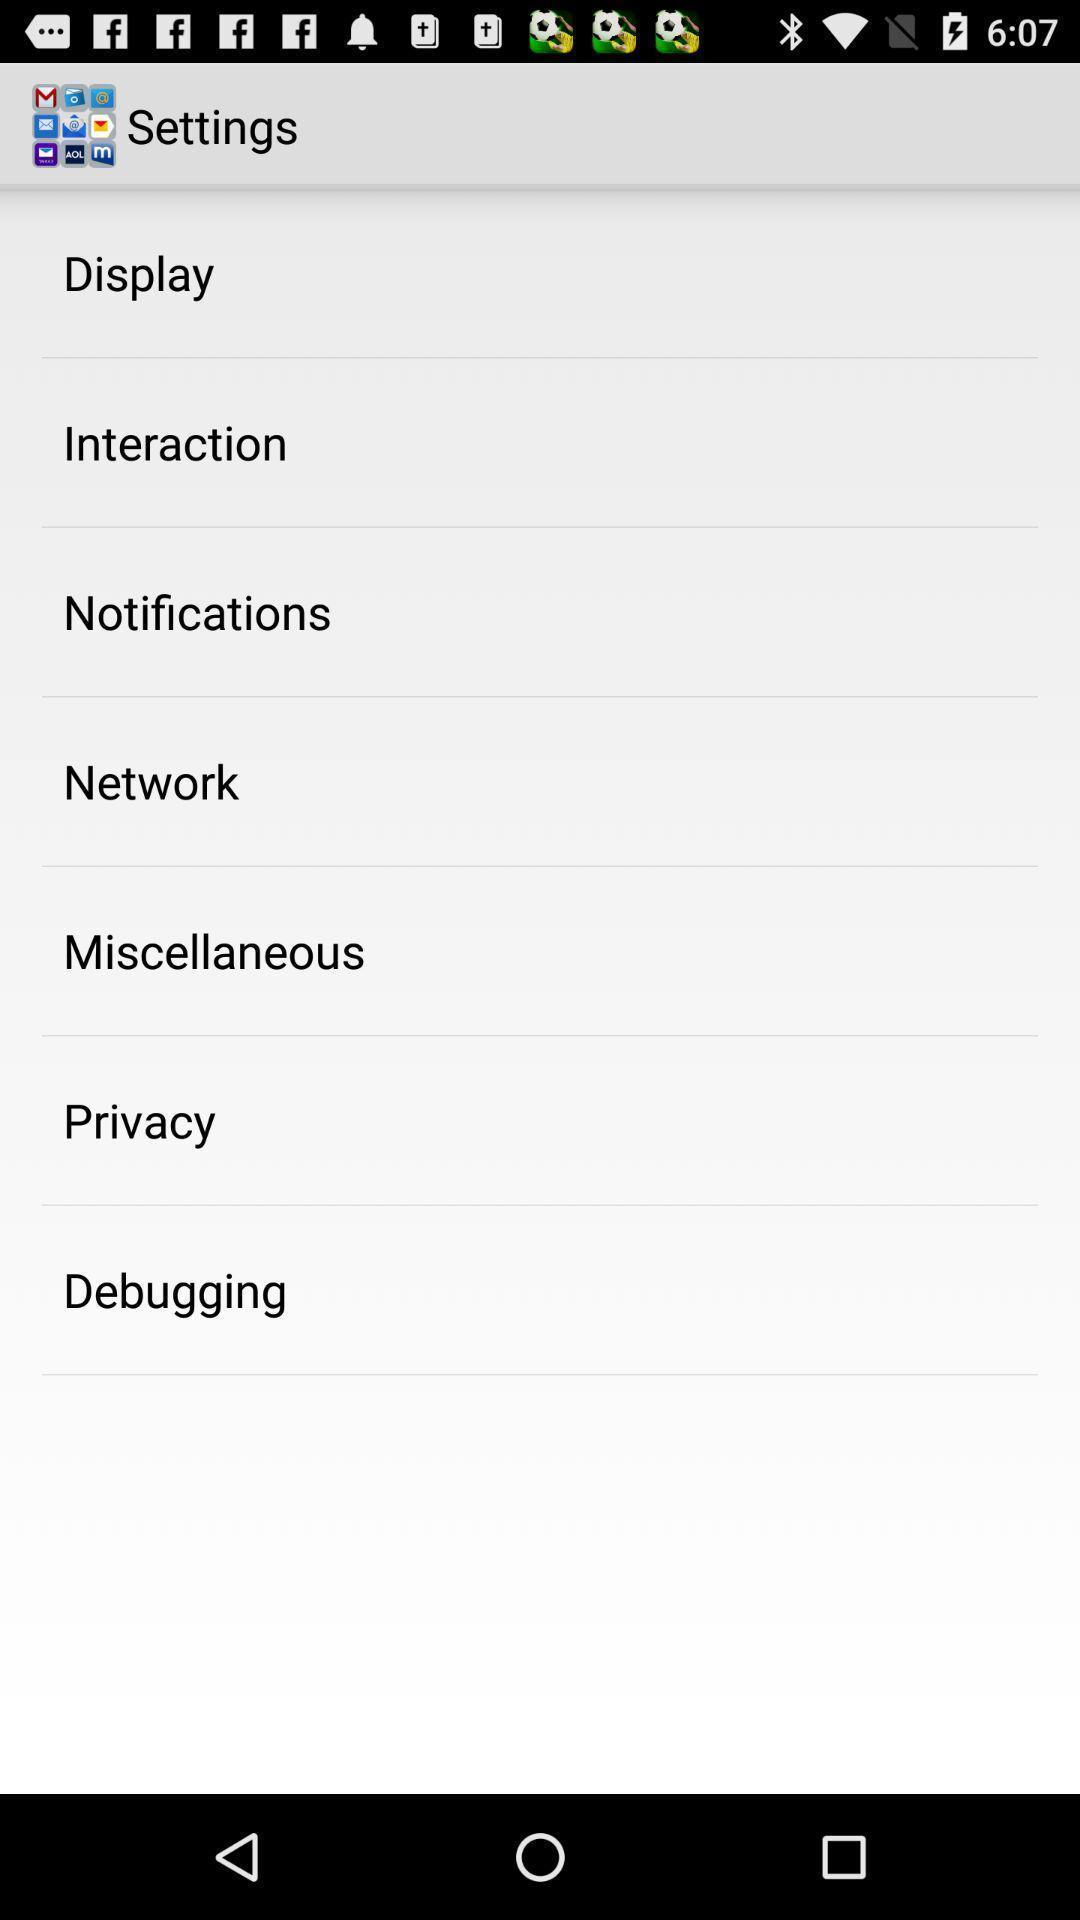Tell me what you see in this picture. Screen displaying the settings page. 